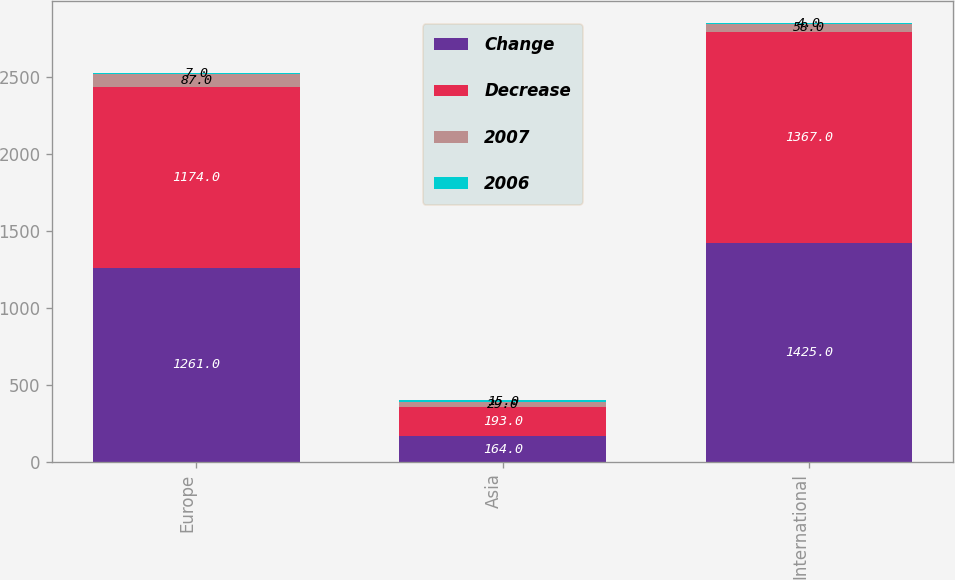<chart> <loc_0><loc_0><loc_500><loc_500><stacked_bar_chart><ecel><fcel>Europe<fcel>Asia<fcel>International<nl><fcel>Change<fcel>1261<fcel>164<fcel>1425<nl><fcel>Decrease<fcel>1174<fcel>193<fcel>1367<nl><fcel>2007<fcel>87<fcel>29<fcel>58<nl><fcel>2006<fcel>7<fcel>15<fcel>4<nl></chart> 